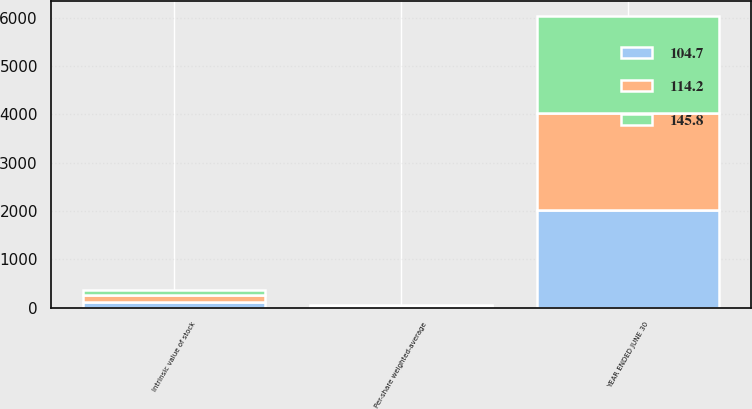<chart> <loc_0><loc_0><loc_500><loc_500><stacked_bar_chart><ecel><fcel>YEAR ENDED JUNE 30<fcel>Per-share weighted-average<fcel>Intrinsic value of stock<nl><fcel>104.7<fcel>2015<fcel>22.44<fcel>114.2<nl><fcel>145.8<fcel>2014<fcel>23.13<fcel>104.7<nl><fcel>114.2<fcel>2013<fcel>20.3<fcel>145.8<nl></chart> 